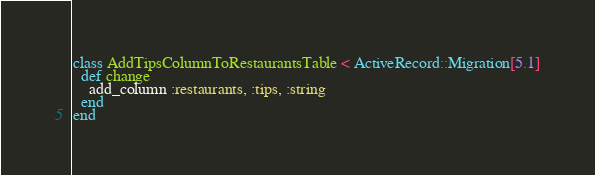Convert code to text. <code><loc_0><loc_0><loc_500><loc_500><_Ruby_>class AddTipsColumnToRestaurantsTable < ActiveRecord::Migration[5.1]
  def change
    add_column :restaurants, :tips, :string
  end
end
</code> 